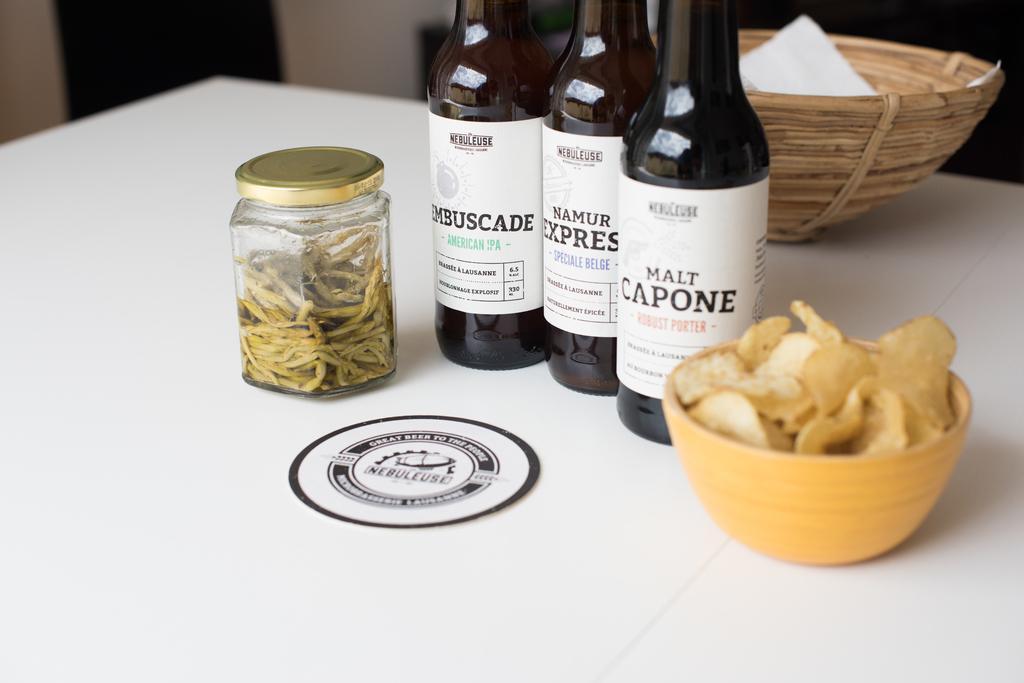In one or two sentences, can you explain what this image depicts? In this image i can see 3 bottles, a jar, a bowl with chips and a basket on the table. 